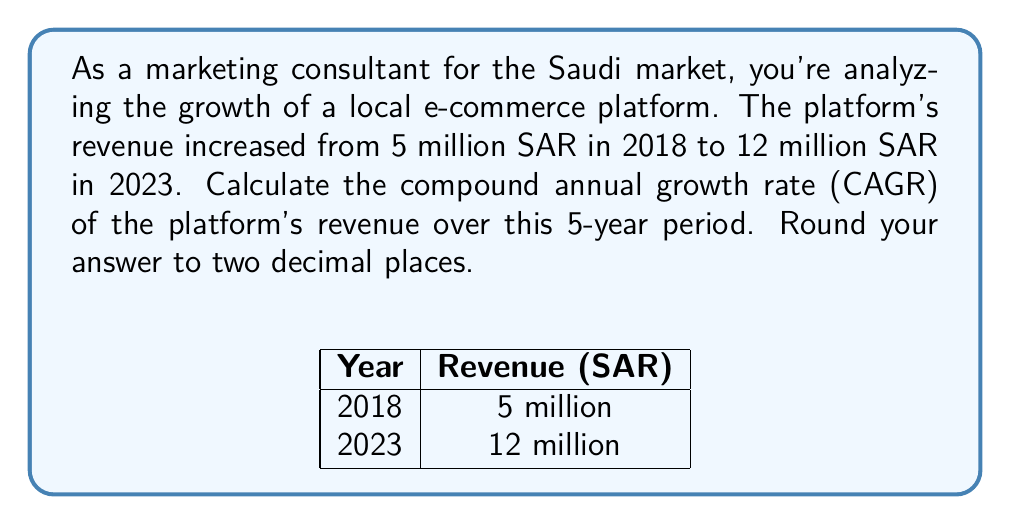Can you solve this math problem? To calculate the Compound Annual Growth Rate (CAGR), we'll use the formula:

$$ CAGR = \left(\frac{Ending Value}{Beginning Value}\right)^{\frac{1}{n}} - 1 $$

Where:
- Ending Value = 12 million SAR
- Beginning Value = 5 million SAR
- n = 5 years

Let's solve step-by-step:

1) Plug the values into the formula:

   $$ CAGR = \left(\frac{12}{5}\right)^{\frac{1}{5}} - 1 $$

2) Simplify inside the parentheses:

   $$ CAGR = (2.4)^{\frac{1}{5}} - 1 $$

3) To calculate this, we can use logarithms:

   $$ CAGR = e^{\ln(2.4) \cdot \frac{1}{5}} - 1 $$

4) Calculate:
   
   $$ CAGR = e^{0.17520 \cdot 0.2} - 1 $$
   $$ CAGR = e^{0.03504} - 1 $$
   $$ CAGR = 1.03566 - 1 $$
   $$ CAGR = 0.03566 $$

5) Convert to percentage and round to two decimal places:

   $$ CAGR = 19.16\% $$

Therefore, the compound annual growth rate is approximately 19.16%.
Answer: 19.16% 